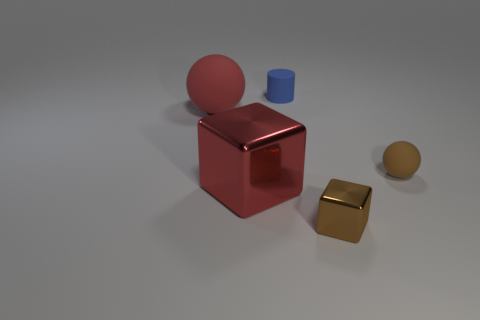Could you describe the lighting in the scene? The lighting in the scene seems diffuse, with soft shadows cast by the objects, indicating a bright, indirect light source, possibly overhead. 